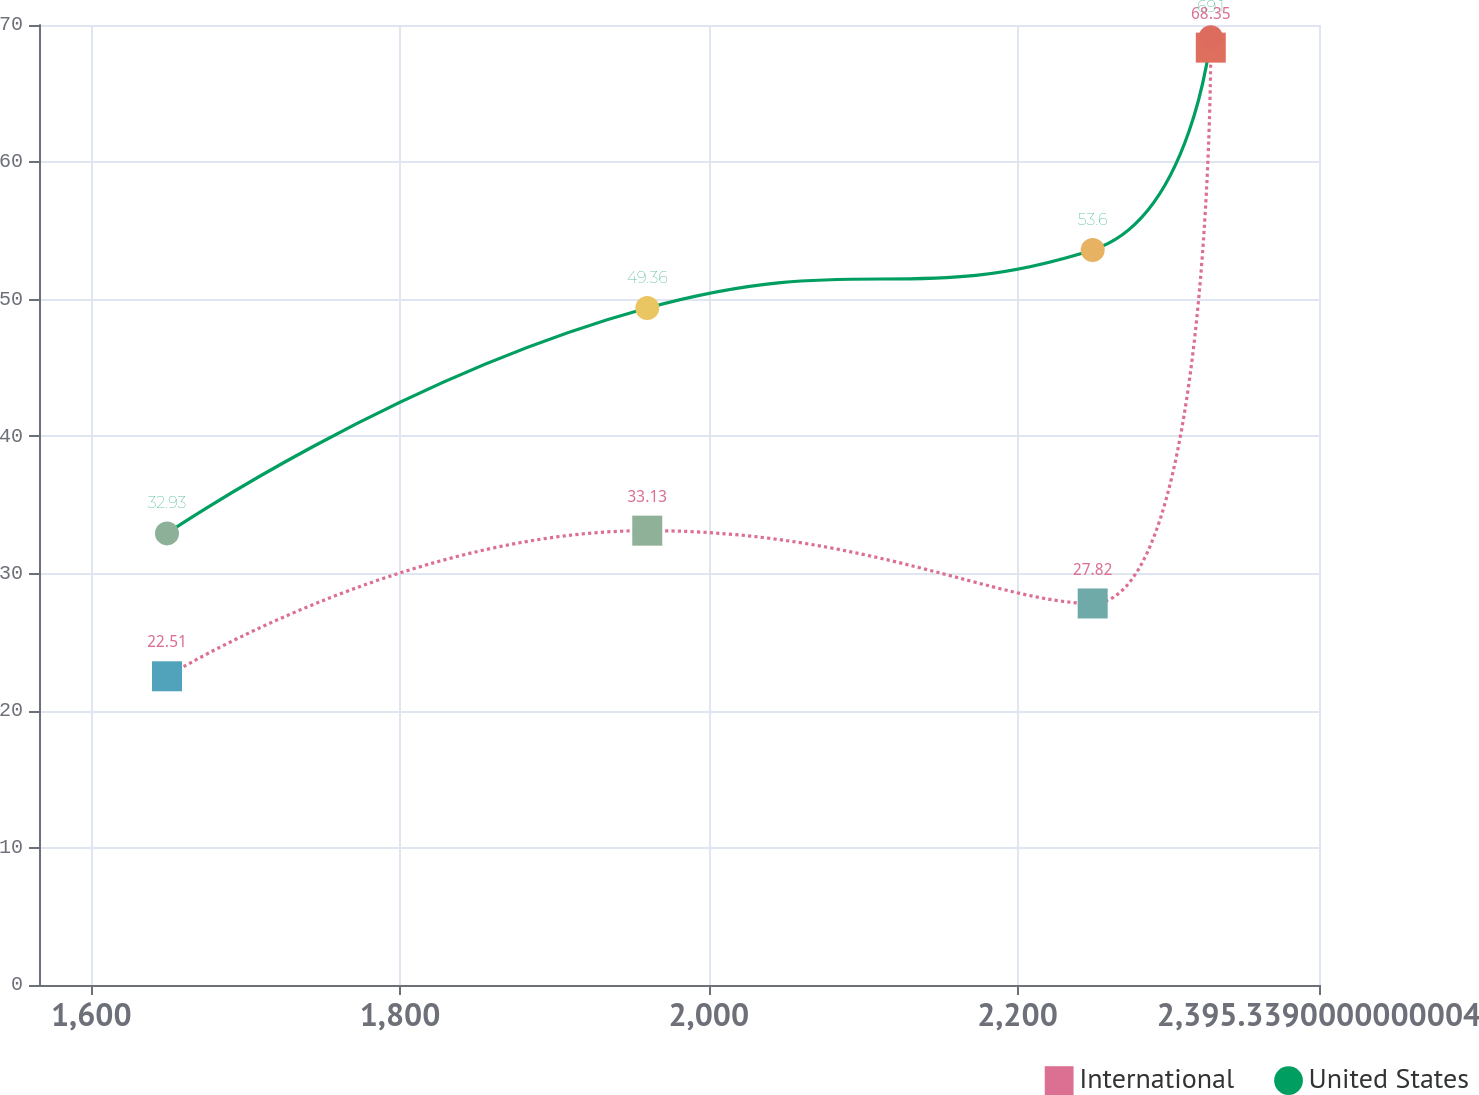Convert chart to OTSL. <chart><loc_0><loc_0><loc_500><loc_500><line_chart><ecel><fcel>International<fcel>United States<nl><fcel>1649.05<fcel>22.51<fcel>32.93<nl><fcel>1960.18<fcel>33.13<fcel>49.36<nl><fcel>2248.73<fcel>27.82<fcel>53.6<nl><fcel>2325.24<fcel>68.35<fcel>69.1<nl><fcel>2401.75<fcel>56.55<fcel>64.41<nl><fcel>2478.26<fcel>75.58<fcel>75.29<nl></chart> 